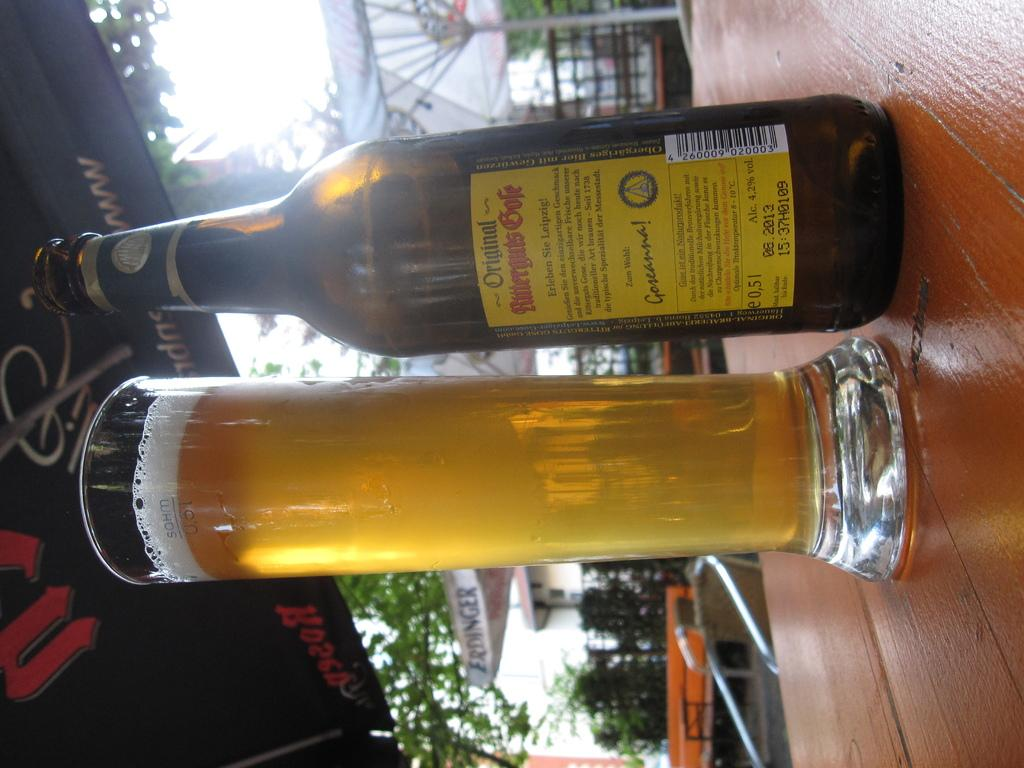Provide a one-sentence caption for the provided image. a bottle and a glass with the bottle saying original on it. 